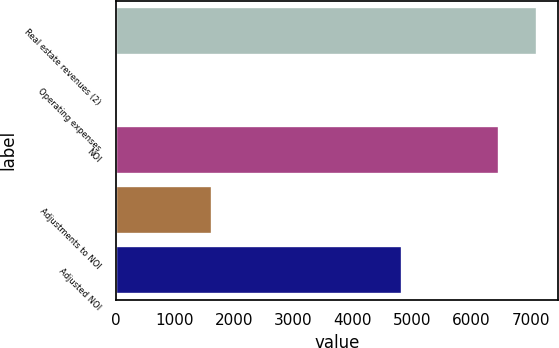<chart> <loc_0><loc_0><loc_500><loc_500><bar_chart><fcel>Real estate revenues (2)<fcel>Operating expenses<fcel>NOI<fcel>Adjustments to NOI<fcel>Adjusted NOI<nl><fcel>7103.8<fcel>6<fcel>6458<fcel>1625<fcel>4833<nl></chart> 